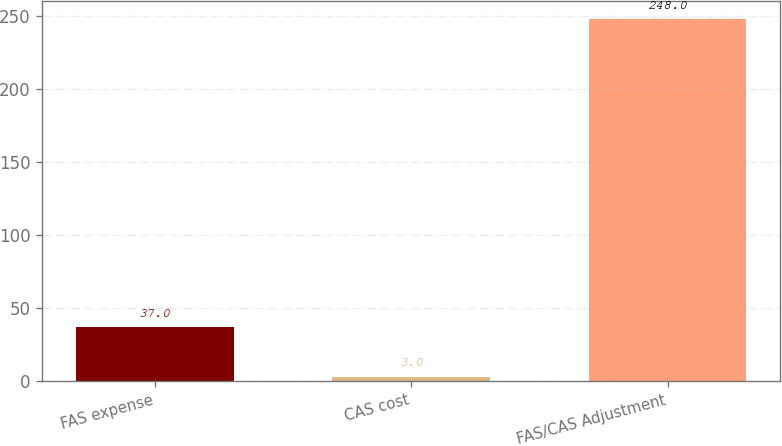Convert chart to OTSL. <chart><loc_0><loc_0><loc_500><loc_500><bar_chart><fcel>FAS expense<fcel>CAS cost<fcel>FAS/CAS Adjustment<nl><fcel>37<fcel>3<fcel>248<nl></chart> 